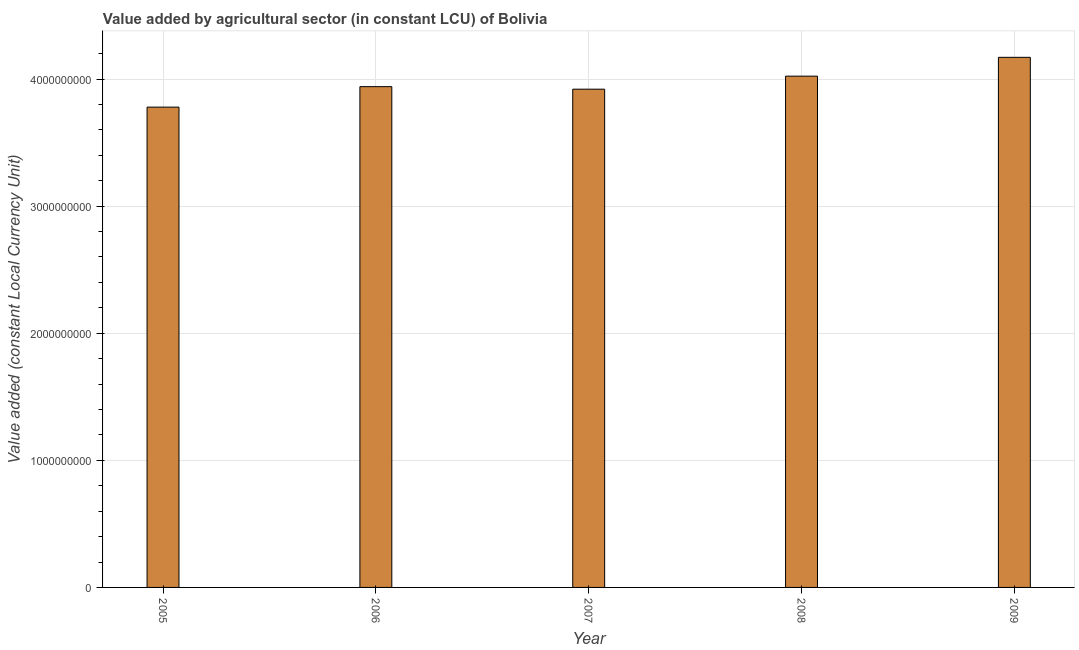Does the graph contain any zero values?
Make the answer very short. No. What is the title of the graph?
Ensure brevity in your answer.  Value added by agricultural sector (in constant LCU) of Bolivia. What is the label or title of the X-axis?
Make the answer very short. Year. What is the label or title of the Y-axis?
Provide a short and direct response. Value added (constant Local Currency Unit). What is the value added by agriculture sector in 2005?
Your response must be concise. 3.78e+09. Across all years, what is the maximum value added by agriculture sector?
Give a very brief answer. 4.17e+09. Across all years, what is the minimum value added by agriculture sector?
Ensure brevity in your answer.  3.78e+09. In which year was the value added by agriculture sector maximum?
Keep it short and to the point. 2009. In which year was the value added by agriculture sector minimum?
Your answer should be compact. 2005. What is the sum of the value added by agriculture sector?
Offer a terse response. 1.98e+1. What is the difference between the value added by agriculture sector in 2007 and 2008?
Give a very brief answer. -1.03e+08. What is the average value added by agriculture sector per year?
Offer a terse response. 3.97e+09. What is the median value added by agriculture sector?
Your answer should be compact. 3.94e+09. In how many years, is the value added by agriculture sector greater than 3000000000 LCU?
Offer a very short reply. 5. What is the ratio of the value added by agriculture sector in 2005 to that in 2009?
Your answer should be compact. 0.91. Is the value added by agriculture sector in 2007 less than that in 2008?
Your answer should be very brief. Yes. What is the difference between the highest and the second highest value added by agriculture sector?
Offer a terse response. 1.48e+08. What is the difference between the highest and the lowest value added by agriculture sector?
Provide a succinct answer. 3.92e+08. What is the Value added (constant Local Currency Unit) of 2005?
Provide a short and direct response. 3.78e+09. What is the Value added (constant Local Currency Unit) of 2006?
Offer a terse response. 3.94e+09. What is the Value added (constant Local Currency Unit) of 2007?
Provide a succinct answer. 3.92e+09. What is the Value added (constant Local Currency Unit) in 2008?
Provide a short and direct response. 4.02e+09. What is the Value added (constant Local Currency Unit) of 2009?
Your answer should be very brief. 4.17e+09. What is the difference between the Value added (constant Local Currency Unit) in 2005 and 2006?
Keep it short and to the point. -1.61e+08. What is the difference between the Value added (constant Local Currency Unit) in 2005 and 2007?
Keep it short and to the point. -1.41e+08. What is the difference between the Value added (constant Local Currency Unit) in 2005 and 2008?
Offer a terse response. -2.44e+08. What is the difference between the Value added (constant Local Currency Unit) in 2005 and 2009?
Give a very brief answer. -3.92e+08. What is the difference between the Value added (constant Local Currency Unit) in 2006 and 2007?
Your answer should be very brief. 1.99e+07. What is the difference between the Value added (constant Local Currency Unit) in 2006 and 2008?
Make the answer very short. -8.26e+07. What is the difference between the Value added (constant Local Currency Unit) in 2006 and 2009?
Offer a terse response. -2.31e+08. What is the difference between the Value added (constant Local Currency Unit) in 2007 and 2008?
Keep it short and to the point. -1.03e+08. What is the difference between the Value added (constant Local Currency Unit) in 2007 and 2009?
Offer a very short reply. -2.51e+08. What is the difference between the Value added (constant Local Currency Unit) in 2008 and 2009?
Ensure brevity in your answer.  -1.48e+08. What is the ratio of the Value added (constant Local Currency Unit) in 2005 to that in 2006?
Your response must be concise. 0.96. What is the ratio of the Value added (constant Local Currency Unit) in 2005 to that in 2007?
Provide a succinct answer. 0.96. What is the ratio of the Value added (constant Local Currency Unit) in 2005 to that in 2008?
Give a very brief answer. 0.94. What is the ratio of the Value added (constant Local Currency Unit) in 2005 to that in 2009?
Your response must be concise. 0.91. What is the ratio of the Value added (constant Local Currency Unit) in 2006 to that in 2008?
Provide a short and direct response. 0.98. What is the ratio of the Value added (constant Local Currency Unit) in 2006 to that in 2009?
Your response must be concise. 0.94. 